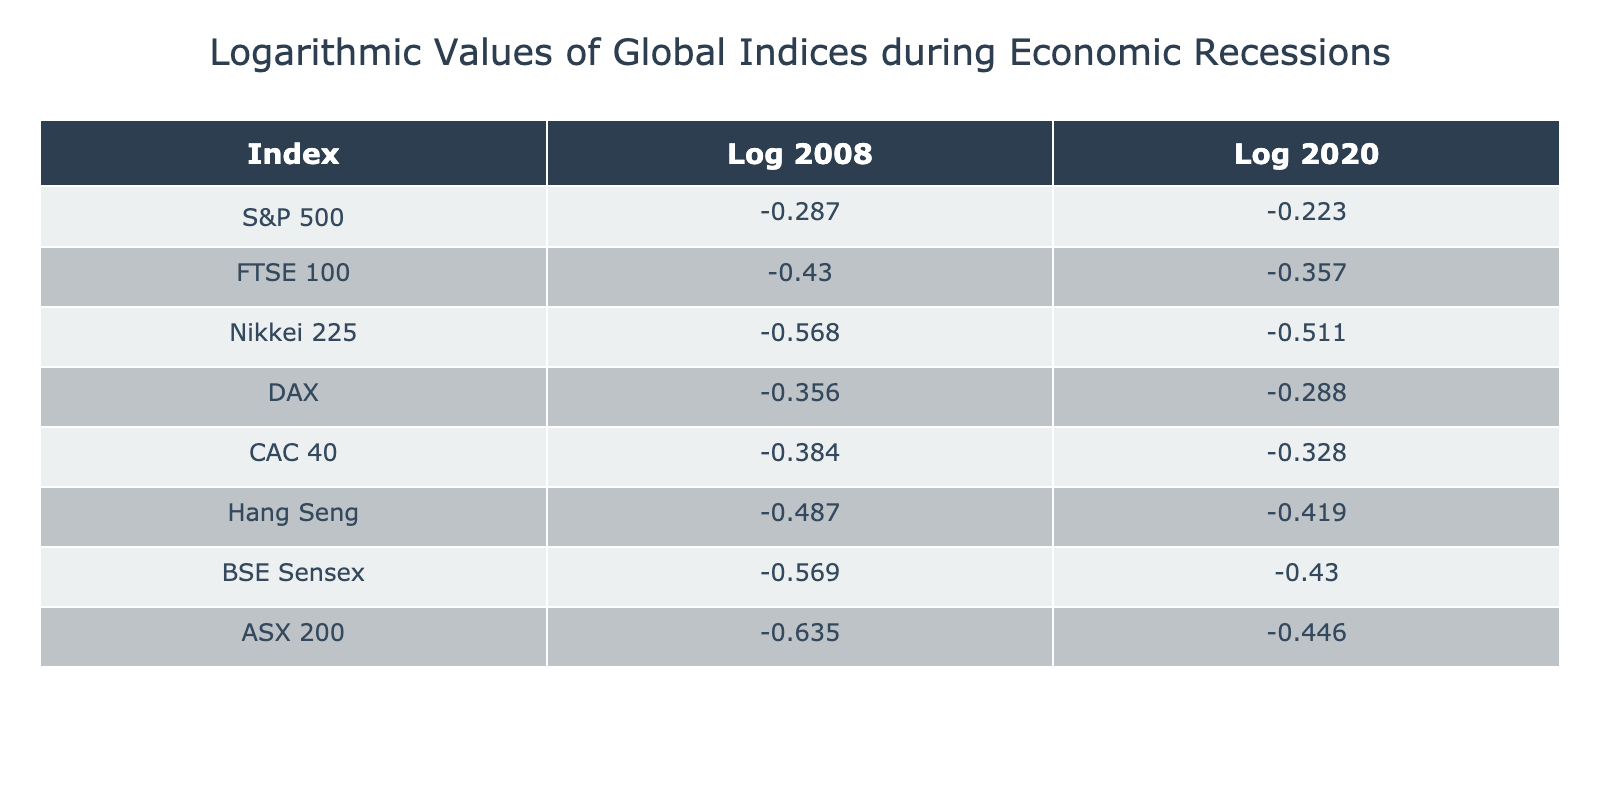What is the logarithmic value of the S&P 500 during the 2008 recession? The table shows that the logarithmic value for the S&P 500 during the 2008 recession is -0.287.
Answer: -0.287 Which index had the lowest logarithmic value during the 2020 recession? By looking at the Log_2020 column, the index with the lowest logarithmic value is the ASX 200, which is -0.446.
Answer: ASX 200 What is the average logarithmic value of the FTSE 100 and DAX during the 2008 recession? The logarithmic values for FTSE 100 and DAX during the 2008 recession are -0.430 and -0.356, respectively. To find the average: (-0.430 + -0.356) / 2 = -0.393.
Answer: -0.393 Is the logarithmic value of the Nikkei 225 during the 2020 recession higher than that of the Hang Seng? The logarithmic values during the 2020 recession are -0.511 for Nikkei 225 and -0.419 for Hang Seng. Since -0.511 is less than -0.419, the statement is false.
Answer: No What is the difference in logarithmic values between the BSE Sensex and Hang Seng during the 2020 recession? BSE Sensex has a logarithmic value of -0.430 and Hang Seng has -0.419. The difference is calculated as -0.430 - (-0.419) = -0.011.
Answer: -0.011 What is the highest logarithmic value recorded across all indices during the 2008 recession? Reviewing the Log_2008 column, the maximum value is -0.287 for the S&P 500, which is the highest among all indices during this period.
Answer: -0.287 Are the logarithmic values during the 2020 recession consistently higher than those in the 2008 recession for all indices? By comparing the Log_2008 and Log_2020 values across all indices, we see that the values for 2020 are not consistently higher. For example, the ASX 200 decreased from -0.635 to -0.446. Hence, the statement is false.
Answer: No How does the logarithmic value of the CAC 40 compare to that of the FTSE 100 during the 2020 recession? The values are -0.328 for CAC 40 and -0.357 for FTSE 100 during the 2020 recession. Since -0.328 is higher than -0.357, CAC 40 has a higher value compared to FTSE 100.
Answer: Higher than What is the sum of the logarithmic values for the S&P 500 and DAX during the 2008 recession? The logarithmic values for S&P 500 and DAX are -0.287 and -0.356, respectively. The sum is -0.287 + (-0.356) = -0.643.
Answer: -0.643 